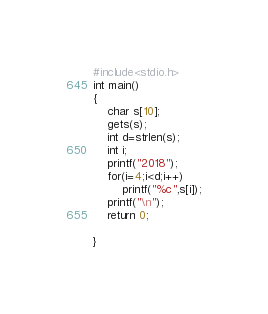Convert code to text. <code><loc_0><loc_0><loc_500><loc_500><_C_>#include<stdio.h>
int main()
{
    char s[10];
    gets(s);
    int d=strlen(s);
    int i;
    printf("2018");
    for(i=4;i<d;i++)
        printf("%c",s[i]);
    printf("\n");
    return 0;

}
</code> 